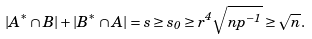Convert formula to latex. <formula><loc_0><loc_0><loc_500><loc_500>| A ^ { * } \cap B | + | B ^ { * } \cap A | = s \geq s _ { 0 } \geq r ^ { 4 } \sqrt { n p ^ { - 1 } } \geq \sqrt { n } .</formula> 